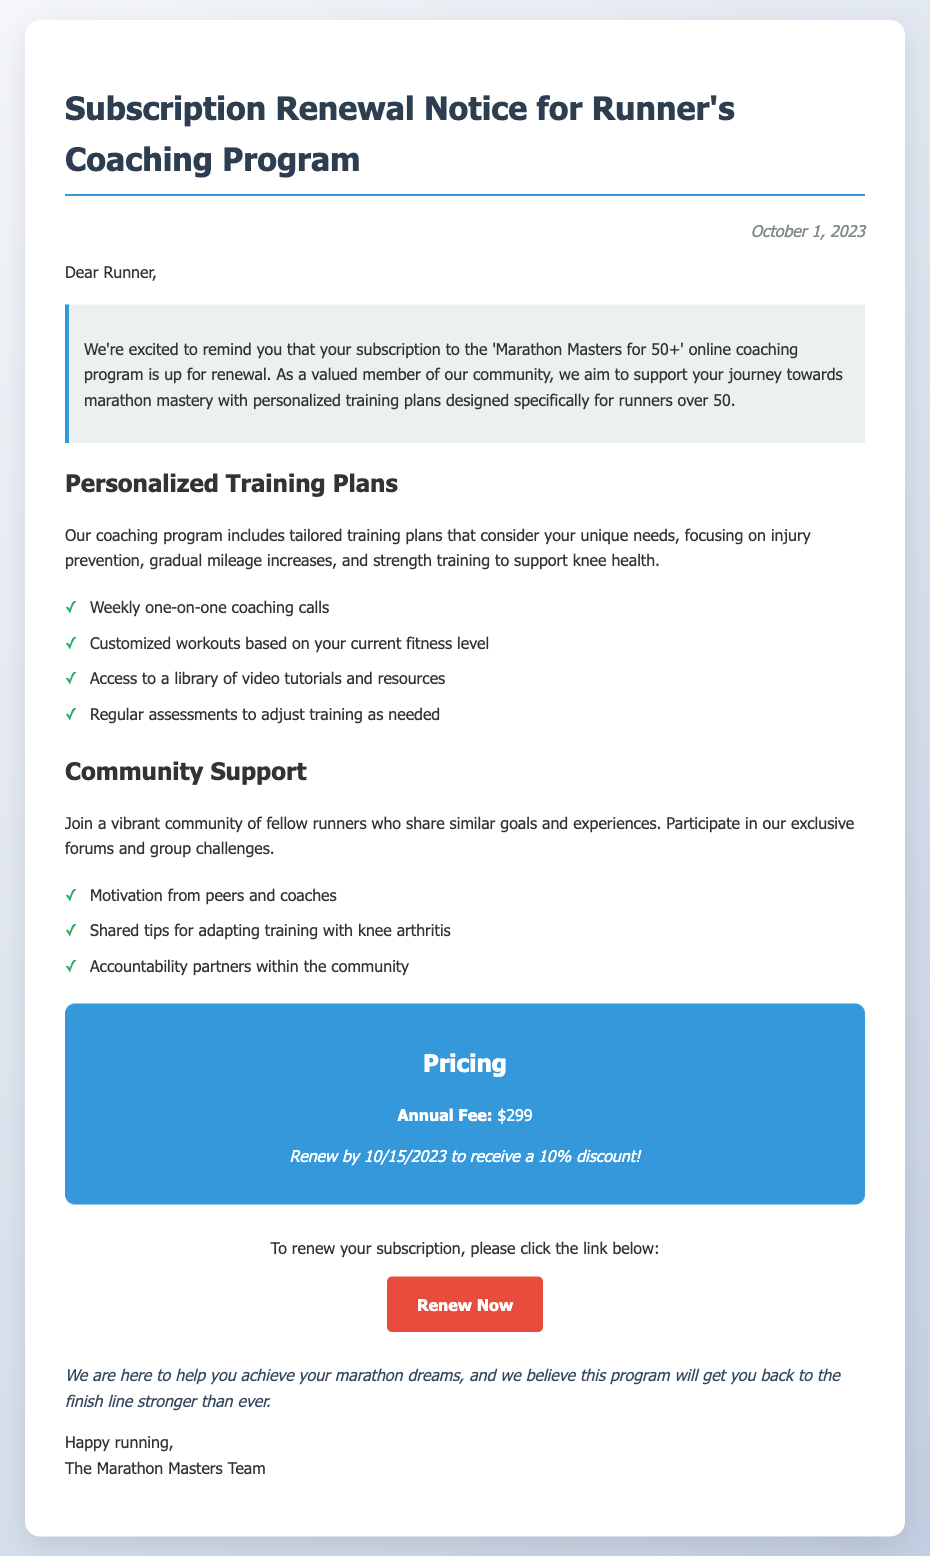What is the annual fee for the coaching program? The document states the annual fee clearly: $299.
Answer: $299 What is the discount available for early renewal? The document mentions a discount of 10% if the subscription is renewed by a specific date: 10/15/2023.
Answer: 10% What date is the subscription renewal notice issued? The specific date on the notice is provided for context: October 1, 2023.
Answer: October 1, 2023 What kind of support does the program emphasize for community members? The document highlights peer motivation, shared tips, and accountability partners as important support types.
Answer: Community Support What is included in the personalized training plans? The document lists key features of the training plans, including injury prevention and strength training for specific needs.
Answer: Tailored training plans What is one benefit of the weekly coaching calls? Weekly coaching calls provide personalized attention to each runner's unique fitness needs and progress.
Answer: One-on-one coaching How can a member renew their subscription? The document provides a direct call-to-action with a link for the renewal process.
Answer: Renew Now What is the focus of the injury prevention strategy mentioned? The documents indicate the focus is on gradual mileage increases and strength training to support knee health.
Answer: Injury prevention What is the goal of the 'Marathon Masters for 50+' program? The primary goal is to support runners over 50 in achieving their marathon aspirations through specialized training.
Answer: Marathon mastery 